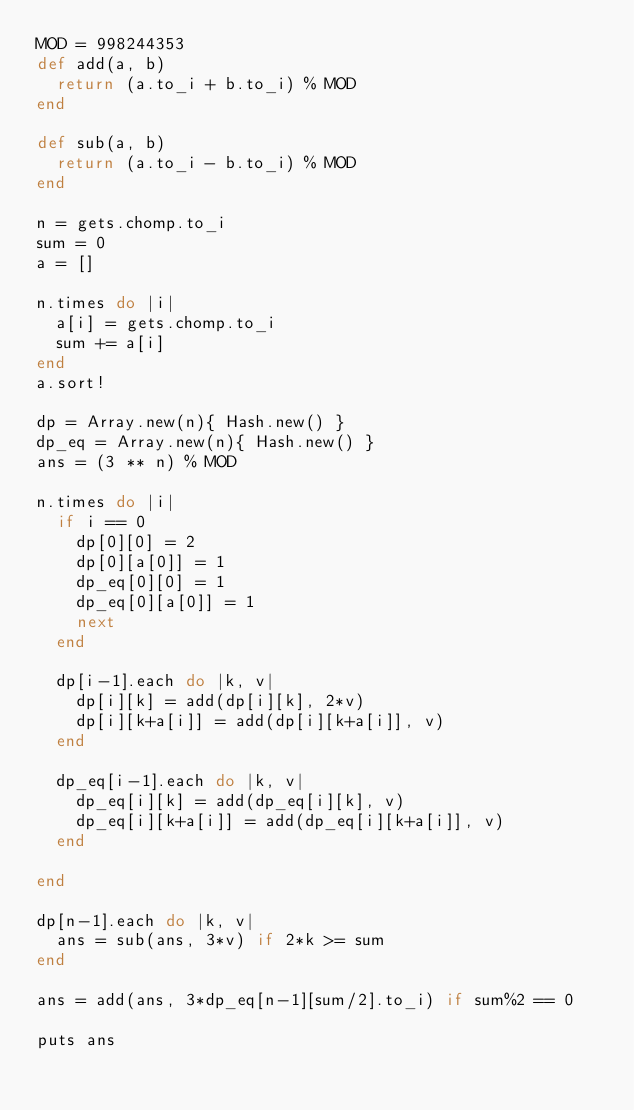Convert code to text. <code><loc_0><loc_0><loc_500><loc_500><_Ruby_>MOD = 998244353
def add(a, b)
  return (a.to_i + b.to_i) % MOD
end

def sub(a, b)
  return (a.to_i - b.to_i) % MOD
end

n = gets.chomp.to_i
sum = 0
a = []

n.times do |i|
  a[i] = gets.chomp.to_i
  sum += a[i]
end
a.sort!

dp = Array.new(n){ Hash.new() }
dp_eq = Array.new(n){ Hash.new() }
ans = (3 ** n) % MOD

n.times do |i|
  if i == 0
    dp[0][0] = 2
    dp[0][a[0]] = 1
    dp_eq[0][0] = 1
    dp_eq[0][a[0]] = 1
    next
  end

  dp[i-1].each do |k, v|
    dp[i][k] = add(dp[i][k], 2*v)
    dp[i][k+a[i]] = add(dp[i][k+a[i]], v)
  end

  dp_eq[i-1].each do |k, v|
    dp_eq[i][k] = add(dp_eq[i][k], v)
    dp_eq[i][k+a[i]] = add(dp_eq[i][k+a[i]], v)
  end

end

dp[n-1].each do |k, v|
  ans = sub(ans, 3*v) if 2*k >= sum
end

ans = add(ans, 3*dp_eq[n-1][sum/2].to_i) if sum%2 == 0

puts ans
</code> 